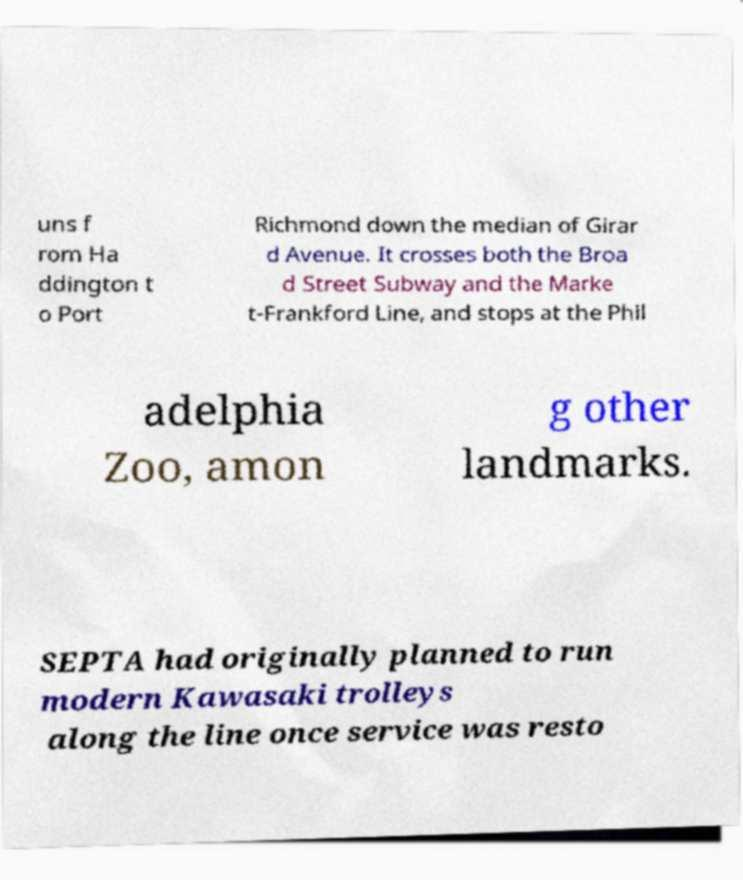Please identify and transcribe the text found in this image. uns f rom Ha ddington t o Port Richmond down the median of Girar d Avenue. It crosses both the Broa d Street Subway and the Marke t-Frankford Line, and stops at the Phil adelphia Zoo, amon g other landmarks. SEPTA had originally planned to run modern Kawasaki trolleys along the line once service was resto 